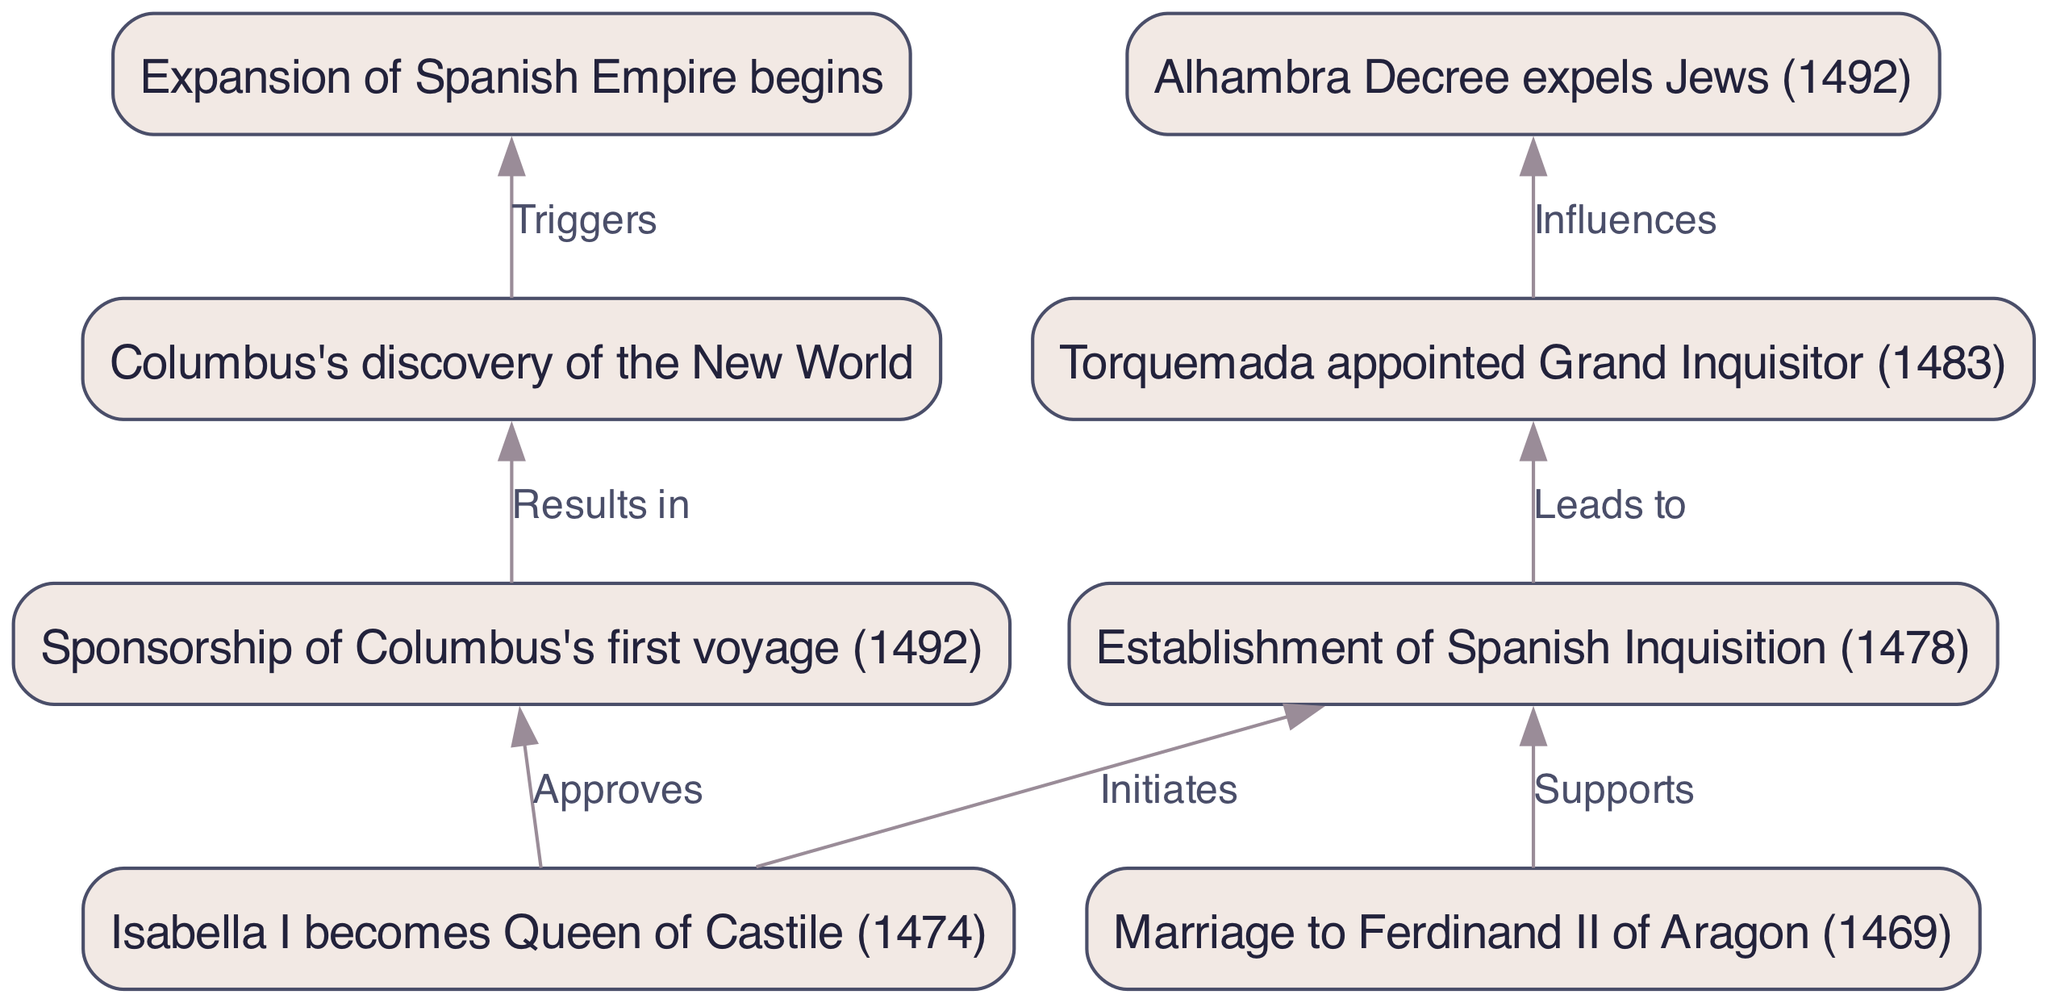What year did Isabella I become Queen of Castile? The diagram indicates that Isabella I becomes Queen of Castile in the year 1474, as depicted in node 1.
Answer: 1474 Who was appointed Grand Inquisitor in 1483? Node 4 of the diagram states that Torquemada is appointed Grand Inquisitor in 1483, showing a specific event in the Spanish Inquisition.
Answer: Torquemada What event leads to the expulsion of Jews in 1492? According to the diagram, the establishment of the Spanish Inquisition in 1478 influences the Alhambra Decree, which expels Jews in 1492, per the connections shown in nodes 3 and 5.
Answer: Establishment of Spanish Inquisition How many nodes are in the diagram? By examining the diagram, we count a total of eight nodes representing different events or actions within Isabella's reign.
Answer: 8 What major event does Columbus's discovery of the New World trigger? The diagram shows that Columbus's discovery of the New World leads to the expansion of the Spanish Empire, depicted in the relationship between nodes 7 and 8.
Answer: Expansion of Spanish Empire What action does Isabella I approve that is linked to Columbus? The diagram illustrates that Isabella I approves the sponsorship of Columbus's first voyage in 1492, reflected in the connection between nodes 1 and 6.
Answer: Sponsorship of Columbus's first voyage What three nodes are directly connected to the establishment of the Spanish Inquisition? The diagram shows that the establishment of the Spanish Inquisition (node 3) is initiated by Isabella's rule (node 1) and supported by Ferdinand (node 2), leading to Torquemada's appointment (node 4).
Answer: Isabella I, Ferdinand II, Torquemada What does the edge from node 6 to node 7 indicate? The edge from node 6 to node 7 indicates that Columbus's sponsorship results in his discovery of the New World, illustrating a direct cause-and-effect relationship in the diagram.
Answer: Results in 